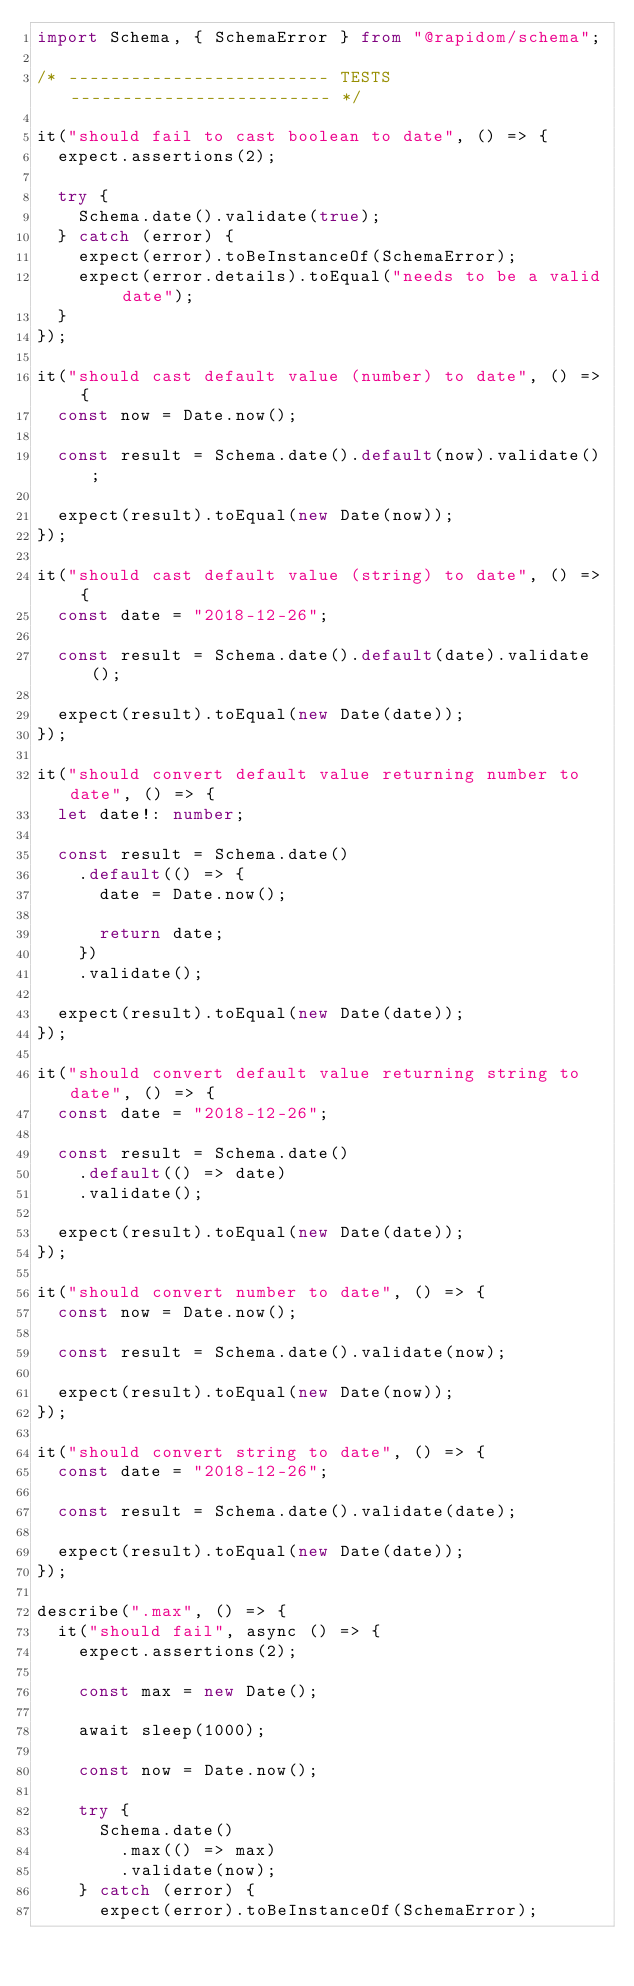<code> <loc_0><loc_0><loc_500><loc_500><_TypeScript_>import Schema, { SchemaError } from "@rapidom/schema";

/* ------------------------- TESTS ------------------------- */

it("should fail to cast boolean to date", () => {
  expect.assertions(2);

  try {
    Schema.date().validate(true);
  } catch (error) {
    expect(error).toBeInstanceOf(SchemaError);
    expect(error.details).toEqual("needs to be a valid date");
  }
});

it("should cast default value (number) to date", () => {
  const now = Date.now();

  const result = Schema.date().default(now).validate();

  expect(result).toEqual(new Date(now));
});

it("should cast default value (string) to date", () => {
  const date = "2018-12-26";

  const result = Schema.date().default(date).validate();

  expect(result).toEqual(new Date(date));
});

it("should convert default value returning number to date", () => {
  let date!: number;

  const result = Schema.date()
    .default(() => {
      date = Date.now();

      return date;
    })
    .validate();

  expect(result).toEqual(new Date(date));
});

it("should convert default value returning string to date", () => {
  const date = "2018-12-26";

  const result = Schema.date()
    .default(() => date)
    .validate();

  expect(result).toEqual(new Date(date));
});

it("should convert number to date", () => {
  const now = Date.now();

  const result = Schema.date().validate(now);

  expect(result).toEqual(new Date(now));
});

it("should convert string to date", () => {
  const date = "2018-12-26";

  const result = Schema.date().validate(date);

  expect(result).toEqual(new Date(date));
});

describe(".max", () => {
  it("should fail", async () => {
    expect.assertions(2);

    const max = new Date();

    await sleep(1000);

    const now = Date.now();

    try {
      Schema.date()
        .max(() => max)
        .validate(now);
    } catch (error) {
      expect(error).toBeInstanceOf(SchemaError);</code> 